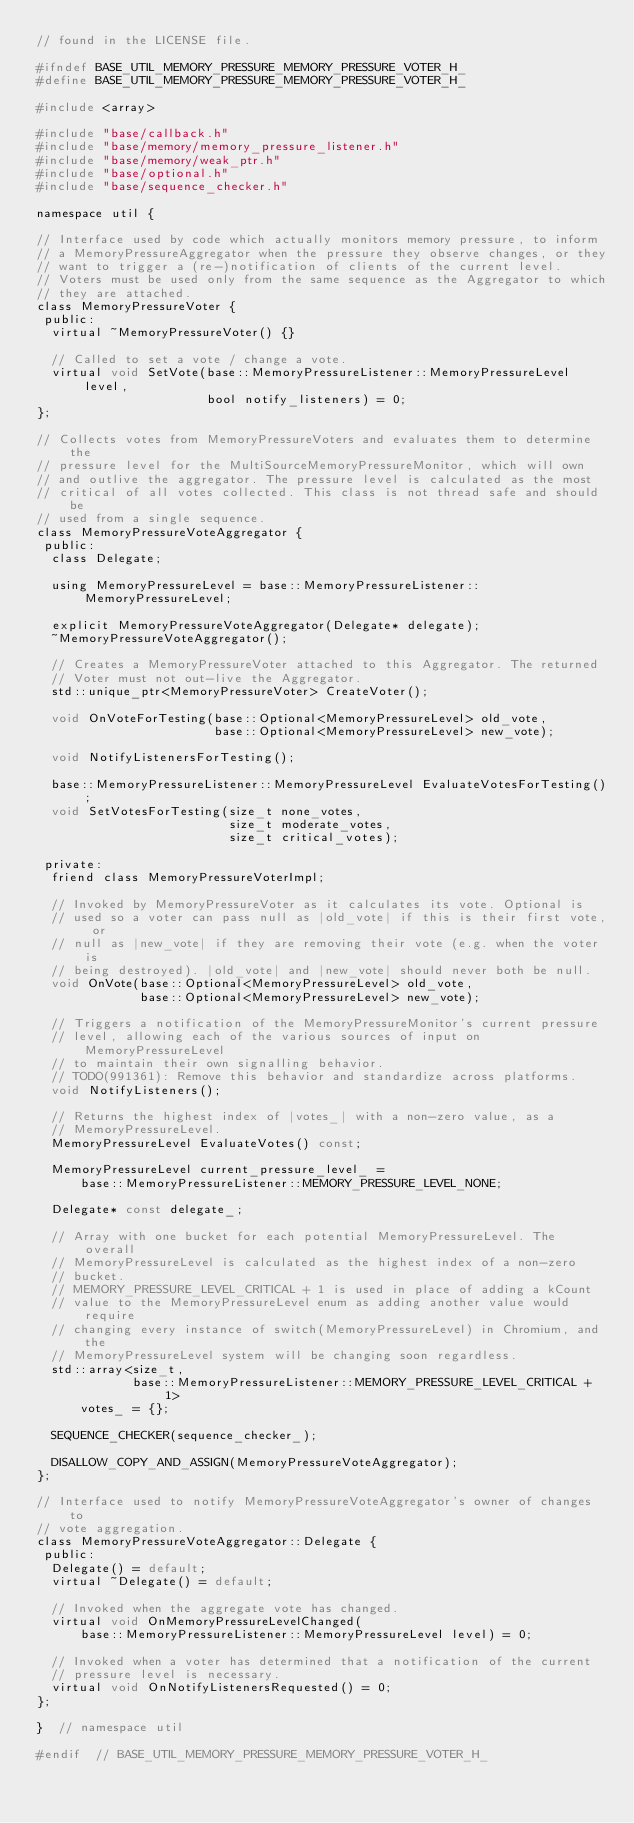<code> <loc_0><loc_0><loc_500><loc_500><_C_>// found in the LICENSE file.

#ifndef BASE_UTIL_MEMORY_PRESSURE_MEMORY_PRESSURE_VOTER_H_
#define BASE_UTIL_MEMORY_PRESSURE_MEMORY_PRESSURE_VOTER_H_

#include <array>

#include "base/callback.h"
#include "base/memory/memory_pressure_listener.h"
#include "base/memory/weak_ptr.h"
#include "base/optional.h"
#include "base/sequence_checker.h"

namespace util {

// Interface used by code which actually monitors memory pressure, to inform
// a MemoryPressureAggregator when the pressure they observe changes, or they
// want to trigger a (re-)notification of clients of the current level.
// Voters must be used only from the same sequence as the Aggregator to which
// they are attached.
class MemoryPressureVoter {
 public:
  virtual ~MemoryPressureVoter() {}

  // Called to set a vote / change a vote.
  virtual void SetVote(base::MemoryPressureListener::MemoryPressureLevel level,
                       bool notify_listeners) = 0;
};

// Collects votes from MemoryPressureVoters and evaluates them to determine the
// pressure level for the MultiSourceMemoryPressureMonitor, which will own
// and outlive the aggregator. The pressure level is calculated as the most
// critical of all votes collected. This class is not thread safe and should be
// used from a single sequence.
class MemoryPressureVoteAggregator {
 public:
  class Delegate;

  using MemoryPressureLevel = base::MemoryPressureListener::MemoryPressureLevel;

  explicit MemoryPressureVoteAggregator(Delegate* delegate);
  ~MemoryPressureVoteAggregator();

  // Creates a MemoryPressureVoter attached to this Aggregator. The returned
  // Voter must not out-live the Aggregator.
  std::unique_ptr<MemoryPressureVoter> CreateVoter();

  void OnVoteForTesting(base::Optional<MemoryPressureLevel> old_vote,
                        base::Optional<MemoryPressureLevel> new_vote);

  void NotifyListenersForTesting();

  base::MemoryPressureListener::MemoryPressureLevel EvaluateVotesForTesting();
  void SetVotesForTesting(size_t none_votes,
                          size_t moderate_votes,
                          size_t critical_votes);

 private:
  friend class MemoryPressureVoterImpl;

  // Invoked by MemoryPressureVoter as it calculates its vote. Optional is
  // used so a voter can pass null as |old_vote| if this is their first vote, or
  // null as |new_vote| if they are removing their vote (e.g. when the voter is
  // being destroyed). |old_vote| and |new_vote| should never both be null.
  void OnVote(base::Optional<MemoryPressureLevel> old_vote,
              base::Optional<MemoryPressureLevel> new_vote);

  // Triggers a notification of the MemoryPressureMonitor's current pressure
  // level, allowing each of the various sources of input on MemoryPressureLevel
  // to maintain their own signalling behavior.
  // TODO(991361): Remove this behavior and standardize across platforms.
  void NotifyListeners();

  // Returns the highest index of |votes_| with a non-zero value, as a
  // MemoryPressureLevel.
  MemoryPressureLevel EvaluateVotes() const;

  MemoryPressureLevel current_pressure_level_ =
      base::MemoryPressureListener::MEMORY_PRESSURE_LEVEL_NONE;

  Delegate* const delegate_;

  // Array with one bucket for each potential MemoryPressureLevel. The overall
  // MemoryPressureLevel is calculated as the highest index of a non-zero
  // bucket.
  // MEMORY_PRESSURE_LEVEL_CRITICAL + 1 is used in place of adding a kCount
  // value to the MemoryPressureLevel enum as adding another value would require
  // changing every instance of switch(MemoryPressureLevel) in Chromium, and the
  // MemoryPressureLevel system will be changing soon regardless.
  std::array<size_t,
             base::MemoryPressureListener::MEMORY_PRESSURE_LEVEL_CRITICAL + 1>
      votes_ = {};

  SEQUENCE_CHECKER(sequence_checker_);

  DISALLOW_COPY_AND_ASSIGN(MemoryPressureVoteAggregator);
};

// Interface used to notify MemoryPressureVoteAggregator's owner of changes to
// vote aggregation.
class MemoryPressureVoteAggregator::Delegate {
 public:
  Delegate() = default;
  virtual ~Delegate() = default;

  // Invoked when the aggregate vote has changed.
  virtual void OnMemoryPressureLevelChanged(
      base::MemoryPressureListener::MemoryPressureLevel level) = 0;

  // Invoked when a voter has determined that a notification of the current
  // pressure level is necessary.
  virtual void OnNotifyListenersRequested() = 0;
};

}  // namespace util

#endif  // BASE_UTIL_MEMORY_PRESSURE_MEMORY_PRESSURE_VOTER_H_
</code> 